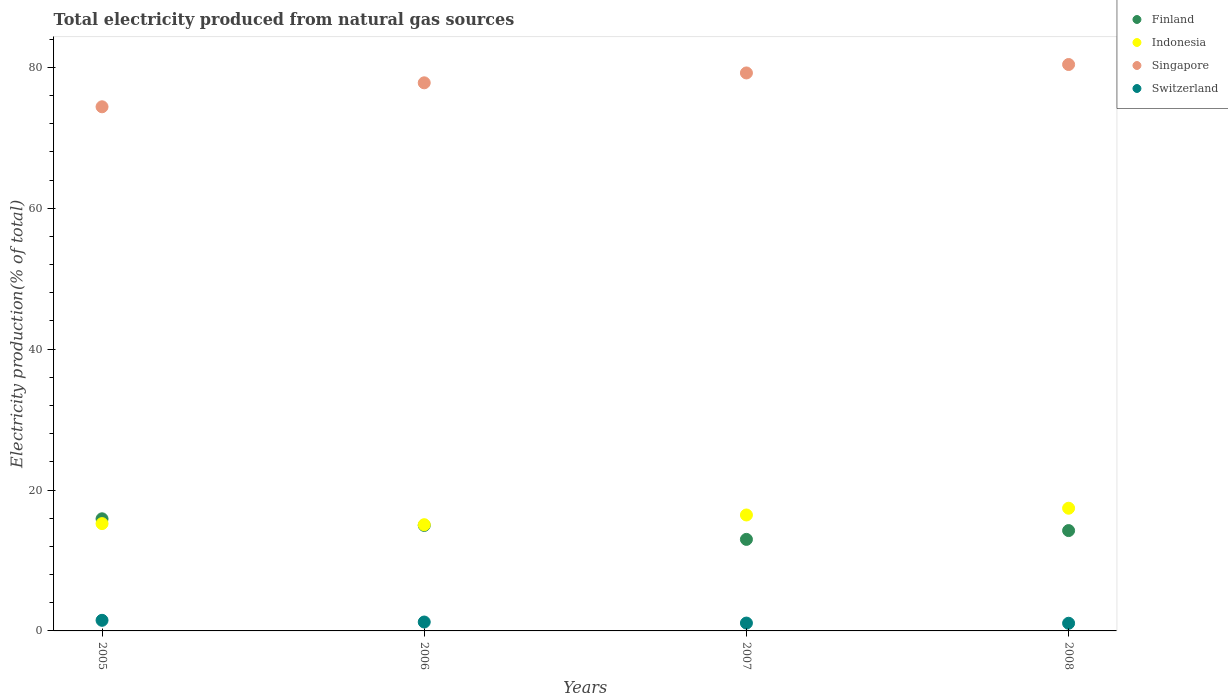Is the number of dotlines equal to the number of legend labels?
Your response must be concise. Yes. What is the total electricity produced in Finland in 2007?
Offer a very short reply. 12.99. Across all years, what is the maximum total electricity produced in Singapore?
Your answer should be compact. 80.4. Across all years, what is the minimum total electricity produced in Finland?
Offer a very short reply. 12.99. In which year was the total electricity produced in Indonesia maximum?
Ensure brevity in your answer.  2008. What is the total total electricity produced in Finland in the graph?
Provide a succinct answer. 58.12. What is the difference between the total electricity produced in Indonesia in 2007 and that in 2008?
Give a very brief answer. -0.96. What is the difference between the total electricity produced in Singapore in 2007 and the total electricity produced in Switzerland in 2008?
Provide a short and direct response. 78.11. What is the average total electricity produced in Finland per year?
Give a very brief answer. 14.53. In the year 2008, what is the difference between the total electricity produced in Switzerland and total electricity produced in Singapore?
Your answer should be very brief. -79.31. What is the ratio of the total electricity produced in Switzerland in 2005 to that in 2006?
Provide a succinct answer. 1.19. What is the difference between the highest and the second highest total electricity produced in Switzerland?
Provide a succinct answer. 0.24. What is the difference between the highest and the lowest total electricity produced in Switzerland?
Keep it short and to the point. 0.42. In how many years, is the total electricity produced in Finland greater than the average total electricity produced in Finland taken over all years?
Provide a short and direct response. 2. Is the sum of the total electricity produced in Indonesia in 2005 and 2007 greater than the maximum total electricity produced in Switzerland across all years?
Make the answer very short. Yes. Is it the case that in every year, the sum of the total electricity produced in Singapore and total electricity produced in Indonesia  is greater than the sum of total electricity produced in Finland and total electricity produced in Switzerland?
Your answer should be compact. No. Is it the case that in every year, the sum of the total electricity produced in Switzerland and total electricity produced in Finland  is greater than the total electricity produced in Singapore?
Offer a very short reply. No. Is the total electricity produced in Switzerland strictly less than the total electricity produced in Finland over the years?
Your answer should be very brief. Yes. How many years are there in the graph?
Offer a terse response. 4. Does the graph contain any zero values?
Offer a terse response. No. Where does the legend appear in the graph?
Your answer should be compact. Top right. How many legend labels are there?
Keep it short and to the point. 4. What is the title of the graph?
Give a very brief answer. Total electricity produced from natural gas sources. What is the label or title of the X-axis?
Provide a short and direct response. Years. What is the Electricity production(% of total) in Finland in 2005?
Your answer should be compact. 15.91. What is the Electricity production(% of total) of Indonesia in 2005?
Make the answer very short. 15.23. What is the Electricity production(% of total) of Singapore in 2005?
Your response must be concise. 74.4. What is the Electricity production(% of total) of Switzerland in 2005?
Your answer should be compact. 1.51. What is the Electricity production(% of total) in Finland in 2006?
Keep it short and to the point. 14.97. What is the Electricity production(% of total) of Indonesia in 2006?
Keep it short and to the point. 15.08. What is the Electricity production(% of total) in Singapore in 2006?
Keep it short and to the point. 77.8. What is the Electricity production(% of total) in Switzerland in 2006?
Provide a short and direct response. 1.26. What is the Electricity production(% of total) in Finland in 2007?
Ensure brevity in your answer.  12.99. What is the Electricity production(% of total) of Indonesia in 2007?
Make the answer very short. 16.46. What is the Electricity production(% of total) in Singapore in 2007?
Your answer should be very brief. 79.2. What is the Electricity production(% of total) of Switzerland in 2007?
Offer a terse response. 1.12. What is the Electricity production(% of total) in Finland in 2008?
Your answer should be very brief. 14.24. What is the Electricity production(% of total) of Indonesia in 2008?
Your answer should be compact. 17.42. What is the Electricity production(% of total) in Singapore in 2008?
Give a very brief answer. 80.4. What is the Electricity production(% of total) in Switzerland in 2008?
Make the answer very short. 1.09. Across all years, what is the maximum Electricity production(% of total) in Finland?
Provide a succinct answer. 15.91. Across all years, what is the maximum Electricity production(% of total) of Indonesia?
Ensure brevity in your answer.  17.42. Across all years, what is the maximum Electricity production(% of total) of Singapore?
Provide a succinct answer. 80.4. Across all years, what is the maximum Electricity production(% of total) of Switzerland?
Your answer should be compact. 1.51. Across all years, what is the minimum Electricity production(% of total) in Finland?
Offer a very short reply. 12.99. Across all years, what is the minimum Electricity production(% of total) of Indonesia?
Keep it short and to the point. 15.08. Across all years, what is the minimum Electricity production(% of total) of Singapore?
Your answer should be compact. 74.4. Across all years, what is the minimum Electricity production(% of total) of Switzerland?
Ensure brevity in your answer.  1.09. What is the total Electricity production(% of total) in Finland in the graph?
Provide a succinct answer. 58.12. What is the total Electricity production(% of total) of Indonesia in the graph?
Offer a very short reply. 64.18. What is the total Electricity production(% of total) of Singapore in the graph?
Offer a very short reply. 311.8. What is the total Electricity production(% of total) in Switzerland in the graph?
Make the answer very short. 4.97. What is the difference between the Electricity production(% of total) of Finland in 2005 and that in 2006?
Your answer should be compact. 0.94. What is the difference between the Electricity production(% of total) of Indonesia in 2005 and that in 2006?
Keep it short and to the point. 0.16. What is the difference between the Electricity production(% of total) in Singapore in 2005 and that in 2006?
Provide a succinct answer. -3.4. What is the difference between the Electricity production(% of total) of Switzerland in 2005 and that in 2006?
Keep it short and to the point. 0.24. What is the difference between the Electricity production(% of total) of Finland in 2005 and that in 2007?
Offer a very short reply. 2.92. What is the difference between the Electricity production(% of total) of Indonesia in 2005 and that in 2007?
Keep it short and to the point. -1.22. What is the difference between the Electricity production(% of total) of Singapore in 2005 and that in 2007?
Make the answer very short. -4.8. What is the difference between the Electricity production(% of total) in Switzerland in 2005 and that in 2007?
Provide a succinct answer. 0.39. What is the difference between the Electricity production(% of total) of Finland in 2005 and that in 2008?
Offer a terse response. 1.67. What is the difference between the Electricity production(% of total) of Indonesia in 2005 and that in 2008?
Give a very brief answer. -2.18. What is the difference between the Electricity production(% of total) of Singapore in 2005 and that in 2008?
Offer a very short reply. -6. What is the difference between the Electricity production(% of total) in Switzerland in 2005 and that in 2008?
Your response must be concise. 0.42. What is the difference between the Electricity production(% of total) in Finland in 2006 and that in 2007?
Provide a short and direct response. 1.98. What is the difference between the Electricity production(% of total) of Indonesia in 2006 and that in 2007?
Your answer should be very brief. -1.38. What is the difference between the Electricity production(% of total) in Singapore in 2006 and that in 2007?
Keep it short and to the point. -1.4. What is the difference between the Electricity production(% of total) of Switzerland in 2006 and that in 2007?
Your answer should be compact. 0.15. What is the difference between the Electricity production(% of total) in Finland in 2006 and that in 2008?
Provide a succinct answer. 0.73. What is the difference between the Electricity production(% of total) of Indonesia in 2006 and that in 2008?
Offer a very short reply. -2.34. What is the difference between the Electricity production(% of total) of Singapore in 2006 and that in 2008?
Your answer should be compact. -2.6. What is the difference between the Electricity production(% of total) in Switzerland in 2006 and that in 2008?
Keep it short and to the point. 0.17. What is the difference between the Electricity production(% of total) in Finland in 2007 and that in 2008?
Your answer should be very brief. -1.25. What is the difference between the Electricity production(% of total) of Indonesia in 2007 and that in 2008?
Provide a succinct answer. -0.96. What is the difference between the Electricity production(% of total) of Singapore in 2007 and that in 2008?
Give a very brief answer. -1.2. What is the difference between the Electricity production(% of total) of Switzerland in 2007 and that in 2008?
Offer a terse response. 0.03. What is the difference between the Electricity production(% of total) of Finland in 2005 and the Electricity production(% of total) of Indonesia in 2006?
Provide a short and direct response. 0.84. What is the difference between the Electricity production(% of total) in Finland in 2005 and the Electricity production(% of total) in Singapore in 2006?
Your answer should be compact. -61.89. What is the difference between the Electricity production(% of total) in Finland in 2005 and the Electricity production(% of total) in Switzerland in 2006?
Offer a very short reply. 14.65. What is the difference between the Electricity production(% of total) in Indonesia in 2005 and the Electricity production(% of total) in Singapore in 2006?
Your response must be concise. -62.57. What is the difference between the Electricity production(% of total) of Indonesia in 2005 and the Electricity production(% of total) of Switzerland in 2006?
Offer a very short reply. 13.97. What is the difference between the Electricity production(% of total) in Singapore in 2005 and the Electricity production(% of total) in Switzerland in 2006?
Offer a terse response. 73.14. What is the difference between the Electricity production(% of total) in Finland in 2005 and the Electricity production(% of total) in Indonesia in 2007?
Your response must be concise. -0.54. What is the difference between the Electricity production(% of total) of Finland in 2005 and the Electricity production(% of total) of Singapore in 2007?
Your response must be concise. -63.29. What is the difference between the Electricity production(% of total) of Finland in 2005 and the Electricity production(% of total) of Switzerland in 2007?
Provide a succinct answer. 14.8. What is the difference between the Electricity production(% of total) in Indonesia in 2005 and the Electricity production(% of total) in Singapore in 2007?
Give a very brief answer. -63.97. What is the difference between the Electricity production(% of total) of Indonesia in 2005 and the Electricity production(% of total) of Switzerland in 2007?
Offer a terse response. 14.12. What is the difference between the Electricity production(% of total) of Singapore in 2005 and the Electricity production(% of total) of Switzerland in 2007?
Give a very brief answer. 73.28. What is the difference between the Electricity production(% of total) of Finland in 2005 and the Electricity production(% of total) of Indonesia in 2008?
Keep it short and to the point. -1.5. What is the difference between the Electricity production(% of total) of Finland in 2005 and the Electricity production(% of total) of Singapore in 2008?
Your answer should be compact. -64.48. What is the difference between the Electricity production(% of total) in Finland in 2005 and the Electricity production(% of total) in Switzerland in 2008?
Provide a succinct answer. 14.83. What is the difference between the Electricity production(% of total) of Indonesia in 2005 and the Electricity production(% of total) of Singapore in 2008?
Keep it short and to the point. -65.17. What is the difference between the Electricity production(% of total) in Indonesia in 2005 and the Electricity production(% of total) in Switzerland in 2008?
Your answer should be very brief. 14.14. What is the difference between the Electricity production(% of total) in Singapore in 2005 and the Electricity production(% of total) in Switzerland in 2008?
Keep it short and to the point. 73.31. What is the difference between the Electricity production(% of total) in Finland in 2006 and the Electricity production(% of total) in Indonesia in 2007?
Your answer should be very brief. -1.48. What is the difference between the Electricity production(% of total) of Finland in 2006 and the Electricity production(% of total) of Singapore in 2007?
Offer a terse response. -64.23. What is the difference between the Electricity production(% of total) of Finland in 2006 and the Electricity production(% of total) of Switzerland in 2007?
Give a very brief answer. 13.86. What is the difference between the Electricity production(% of total) of Indonesia in 2006 and the Electricity production(% of total) of Singapore in 2007?
Make the answer very short. -64.12. What is the difference between the Electricity production(% of total) in Indonesia in 2006 and the Electricity production(% of total) in Switzerland in 2007?
Provide a succinct answer. 13.96. What is the difference between the Electricity production(% of total) in Singapore in 2006 and the Electricity production(% of total) in Switzerland in 2007?
Offer a terse response. 76.69. What is the difference between the Electricity production(% of total) in Finland in 2006 and the Electricity production(% of total) in Indonesia in 2008?
Make the answer very short. -2.44. What is the difference between the Electricity production(% of total) in Finland in 2006 and the Electricity production(% of total) in Singapore in 2008?
Ensure brevity in your answer.  -65.43. What is the difference between the Electricity production(% of total) in Finland in 2006 and the Electricity production(% of total) in Switzerland in 2008?
Keep it short and to the point. 13.88. What is the difference between the Electricity production(% of total) in Indonesia in 2006 and the Electricity production(% of total) in Singapore in 2008?
Your answer should be compact. -65.32. What is the difference between the Electricity production(% of total) of Indonesia in 2006 and the Electricity production(% of total) of Switzerland in 2008?
Offer a terse response. 13.99. What is the difference between the Electricity production(% of total) of Singapore in 2006 and the Electricity production(% of total) of Switzerland in 2008?
Offer a terse response. 76.71. What is the difference between the Electricity production(% of total) in Finland in 2007 and the Electricity production(% of total) in Indonesia in 2008?
Your answer should be very brief. -4.42. What is the difference between the Electricity production(% of total) in Finland in 2007 and the Electricity production(% of total) in Singapore in 2008?
Ensure brevity in your answer.  -67.41. What is the difference between the Electricity production(% of total) of Finland in 2007 and the Electricity production(% of total) of Switzerland in 2008?
Ensure brevity in your answer.  11.9. What is the difference between the Electricity production(% of total) of Indonesia in 2007 and the Electricity production(% of total) of Singapore in 2008?
Your answer should be compact. -63.94. What is the difference between the Electricity production(% of total) in Indonesia in 2007 and the Electricity production(% of total) in Switzerland in 2008?
Give a very brief answer. 15.37. What is the difference between the Electricity production(% of total) of Singapore in 2007 and the Electricity production(% of total) of Switzerland in 2008?
Your answer should be compact. 78.11. What is the average Electricity production(% of total) of Finland per year?
Your response must be concise. 14.53. What is the average Electricity production(% of total) of Indonesia per year?
Make the answer very short. 16.05. What is the average Electricity production(% of total) of Singapore per year?
Make the answer very short. 77.95. What is the average Electricity production(% of total) of Switzerland per year?
Your answer should be very brief. 1.24. In the year 2005, what is the difference between the Electricity production(% of total) of Finland and Electricity production(% of total) of Indonesia?
Your response must be concise. 0.68. In the year 2005, what is the difference between the Electricity production(% of total) in Finland and Electricity production(% of total) in Singapore?
Provide a short and direct response. -58.48. In the year 2005, what is the difference between the Electricity production(% of total) of Finland and Electricity production(% of total) of Switzerland?
Provide a succinct answer. 14.41. In the year 2005, what is the difference between the Electricity production(% of total) of Indonesia and Electricity production(% of total) of Singapore?
Keep it short and to the point. -59.17. In the year 2005, what is the difference between the Electricity production(% of total) of Indonesia and Electricity production(% of total) of Switzerland?
Keep it short and to the point. 13.73. In the year 2005, what is the difference between the Electricity production(% of total) in Singapore and Electricity production(% of total) in Switzerland?
Ensure brevity in your answer.  72.89. In the year 2006, what is the difference between the Electricity production(% of total) in Finland and Electricity production(% of total) in Indonesia?
Your response must be concise. -0.1. In the year 2006, what is the difference between the Electricity production(% of total) in Finland and Electricity production(% of total) in Singapore?
Offer a very short reply. -62.83. In the year 2006, what is the difference between the Electricity production(% of total) of Finland and Electricity production(% of total) of Switzerland?
Offer a very short reply. 13.71. In the year 2006, what is the difference between the Electricity production(% of total) in Indonesia and Electricity production(% of total) in Singapore?
Your answer should be compact. -62.72. In the year 2006, what is the difference between the Electricity production(% of total) of Indonesia and Electricity production(% of total) of Switzerland?
Make the answer very short. 13.81. In the year 2006, what is the difference between the Electricity production(% of total) in Singapore and Electricity production(% of total) in Switzerland?
Ensure brevity in your answer.  76.54. In the year 2007, what is the difference between the Electricity production(% of total) of Finland and Electricity production(% of total) of Indonesia?
Offer a very short reply. -3.46. In the year 2007, what is the difference between the Electricity production(% of total) in Finland and Electricity production(% of total) in Singapore?
Your response must be concise. -66.21. In the year 2007, what is the difference between the Electricity production(% of total) in Finland and Electricity production(% of total) in Switzerland?
Your response must be concise. 11.88. In the year 2007, what is the difference between the Electricity production(% of total) of Indonesia and Electricity production(% of total) of Singapore?
Make the answer very short. -62.74. In the year 2007, what is the difference between the Electricity production(% of total) of Indonesia and Electricity production(% of total) of Switzerland?
Your answer should be compact. 15.34. In the year 2007, what is the difference between the Electricity production(% of total) of Singapore and Electricity production(% of total) of Switzerland?
Make the answer very short. 78.09. In the year 2008, what is the difference between the Electricity production(% of total) in Finland and Electricity production(% of total) in Indonesia?
Your answer should be compact. -3.17. In the year 2008, what is the difference between the Electricity production(% of total) in Finland and Electricity production(% of total) in Singapore?
Offer a very short reply. -66.16. In the year 2008, what is the difference between the Electricity production(% of total) of Finland and Electricity production(% of total) of Switzerland?
Provide a short and direct response. 13.15. In the year 2008, what is the difference between the Electricity production(% of total) in Indonesia and Electricity production(% of total) in Singapore?
Make the answer very short. -62.98. In the year 2008, what is the difference between the Electricity production(% of total) of Indonesia and Electricity production(% of total) of Switzerland?
Your answer should be very brief. 16.33. In the year 2008, what is the difference between the Electricity production(% of total) in Singapore and Electricity production(% of total) in Switzerland?
Keep it short and to the point. 79.31. What is the ratio of the Electricity production(% of total) in Finland in 2005 to that in 2006?
Offer a terse response. 1.06. What is the ratio of the Electricity production(% of total) in Indonesia in 2005 to that in 2006?
Your answer should be compact. 1.01. What is the ratio of the Electricity production(% of total) of Singapore in 2005 to that in 2006?
Offer a terse response. 0.96. What is the ratio of the Electricity production(% of total) of Switzerland in 2005 to that in 2006?
Offer a very short reply. 1.19. What is the ratio of the Electricity production(% of total) in Finland in 2005 to that in 2007?
Make the answer very short. 1.22. What is the ratio of the Electricity production(% of total) of Indonesia in 2005 to that in 2007?
Your answer should be very brief. 0.93. What is the ratio of the Electricity production(% of total) of Singapore in 2005 to that in 2007?
Your answer should be very brief. 0.94. What is the ratio of the Electricity production(% of total) in Switzerland in 2005 to that in 2007?
Provide a short and direct response. 1.35. What is the ratio of the Electricity production(% of total) in Finland in 2005 to that in 2008?
Provide a short and direct response. 1.12. What is the ratio of the Electricity production(% of total) of Indonesia in 2005 to that in 2008?
Offer a very short reply. 0.87. What is the ratio of the Electricity production(% of total) in Singapore in 2005 to that in 2008?
Your response must be concise. 0.93. What is the ratio of the Electricity production(% of total) of Switzerland in 2005 to that in 2008?
Keep it short and to the point. 1.38. What is the ratio of the Electricity production(% of total) in Finland in 2006 to that in 2007?
Give a very brief answer. 1.15. What is the ratio of the Electricity production(% of total) of Indonesia in 2006 to that in 2007?
Ensure brevity in your answer.  0.92. What is the ratio of the Electricity production(% of total) in Singapore in 2006 to that in 2007?
Offer a very short reply. 0.98. What is the ratio of the Electricity production(% of total) in Switzerland in 2006 to that in 2007?
Your response must be concise. 1.13. What is the ratio of the Electricity production(% of total) in Finland in 2006 to that in 2008?
Ensure brevity in your answer.  1.05. What is the ratio of the Electricity production(% of total) in Indonesia in 2006 to that in 2008?
Your answer should be very brief. 0.87. What is the ratio of the Electricity production(% of total) of Switzerland in 2006 to that in 2008?
Offer a very short reply. 1.16. What is the ratio of the Electricity production(% of total) in Finland in 2007 to that in 2008?
Keep it short and to the point. 0.91. What is the ratio of the Electricity production(% of total) in Indonesia in 2007 to that in 2008?
Keep it short and to the point. 0.94. What is the ratio of the Electricity production(% of total) in Singapore in 2007 to that in 2008?
Ensure brevity in your answer.  0.99. What is the ratio of the Electricity production(% of total) in Switzerland in 2007 to that in 2008?
Offer a terse response. 1.02. What is the difference between the highest and the second highest Electricity production(% of total) of Indonesia?
Give a very brief answer. 0.96. What is the difference between the highest and the second highest Electricity production(% of total) of Singapore?
Offer a very short reply. 1.2. What is the difference between the highest and the second highest Electricity production(% of total) in Switzerland?
Make the answer very short. 0.24. What is the difference between the highest and the lowest Electricity production(% of total) of Finland?
Your answer should be very brief. 2.92. What is the difference between the highest and the lowest Electricity production(% of total) in Indonesia?
Provide a succinct answer. 2.34. What is the difference between the highest and the lowest Electricity production(% of total) in Singapore?
Offer a very short reply. 6. What is the difference between the highest and the lowest Electricity production(% of total) of Switzerland?
Your answer should be compact. 0.42. 